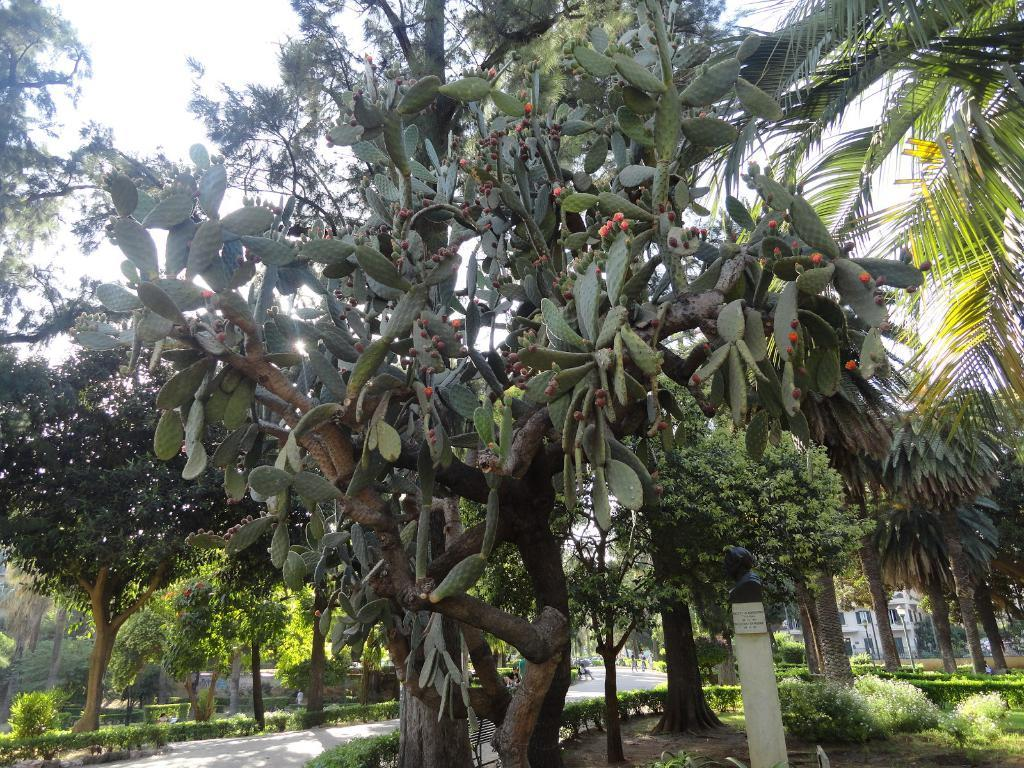What type of vegetation can be seen in the image? There are many trees in the image. What else can be found at the bottom of the image? Plants are present at the bottom of the image. What structure is visible in the image? There is a pole in the image. What type of clouds can be seen in the image? There is no mention of clouds in the provided facts, so we cannot determine if clouds are present in the image. 